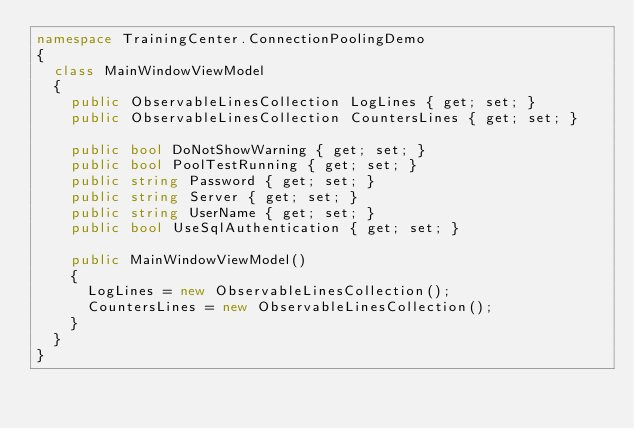Convert code to text. <code><loc_0><loc_0><loc_500><loc_500><_C#_>namespace TrainingCenter.ConnectionPoolingDemo
{
	class MainWindowViewModel
	{
		public ObservableLinesCollection LogLines { get; set; }
		public ObservableLinesCollection CountersLines { get; set; }

		public bool DoNotShowWarning { get; set; }
		public bool PoolTestRunning { get; set; }
		public string Password { get; set; }
		public string Server { get; set; }
		public string UserName { get; set; }
		public bool UseSqlAuthentication { get; set; }

		public MainWindowViewModel()
		{
			LogLines = new ObservableLinesCollection();
			CountersLines = new ObservableLinesCollection();
		}
	}
}
</code> 